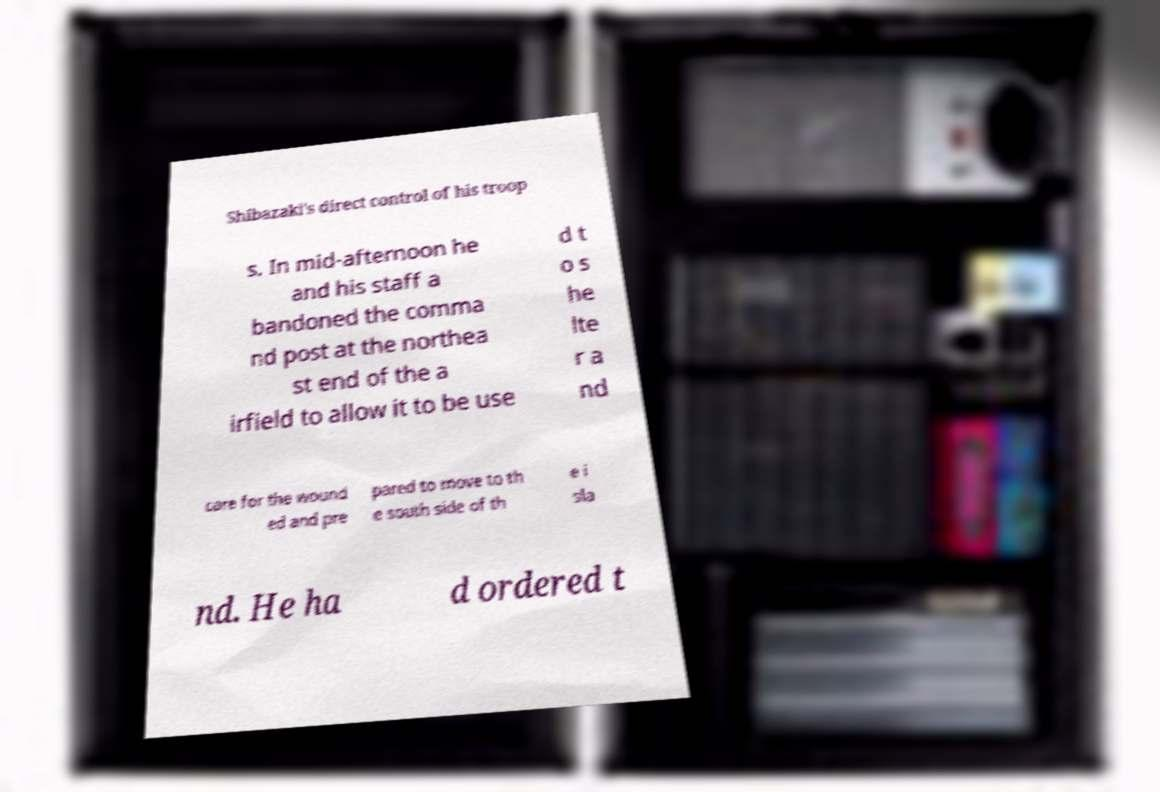For documentation purposes, I need the text within this image transcribed. Could you provide that? Shibazaki's direct control of his troop s. In mid-afternoon he and his staff a bandoned the comma nd post at the northea st end of the a irfield to allow it to be use d t o s he lte r a nd care for the wound ed and pre pared to move to th e south side of th e i sla nd. He ha d ordered t 